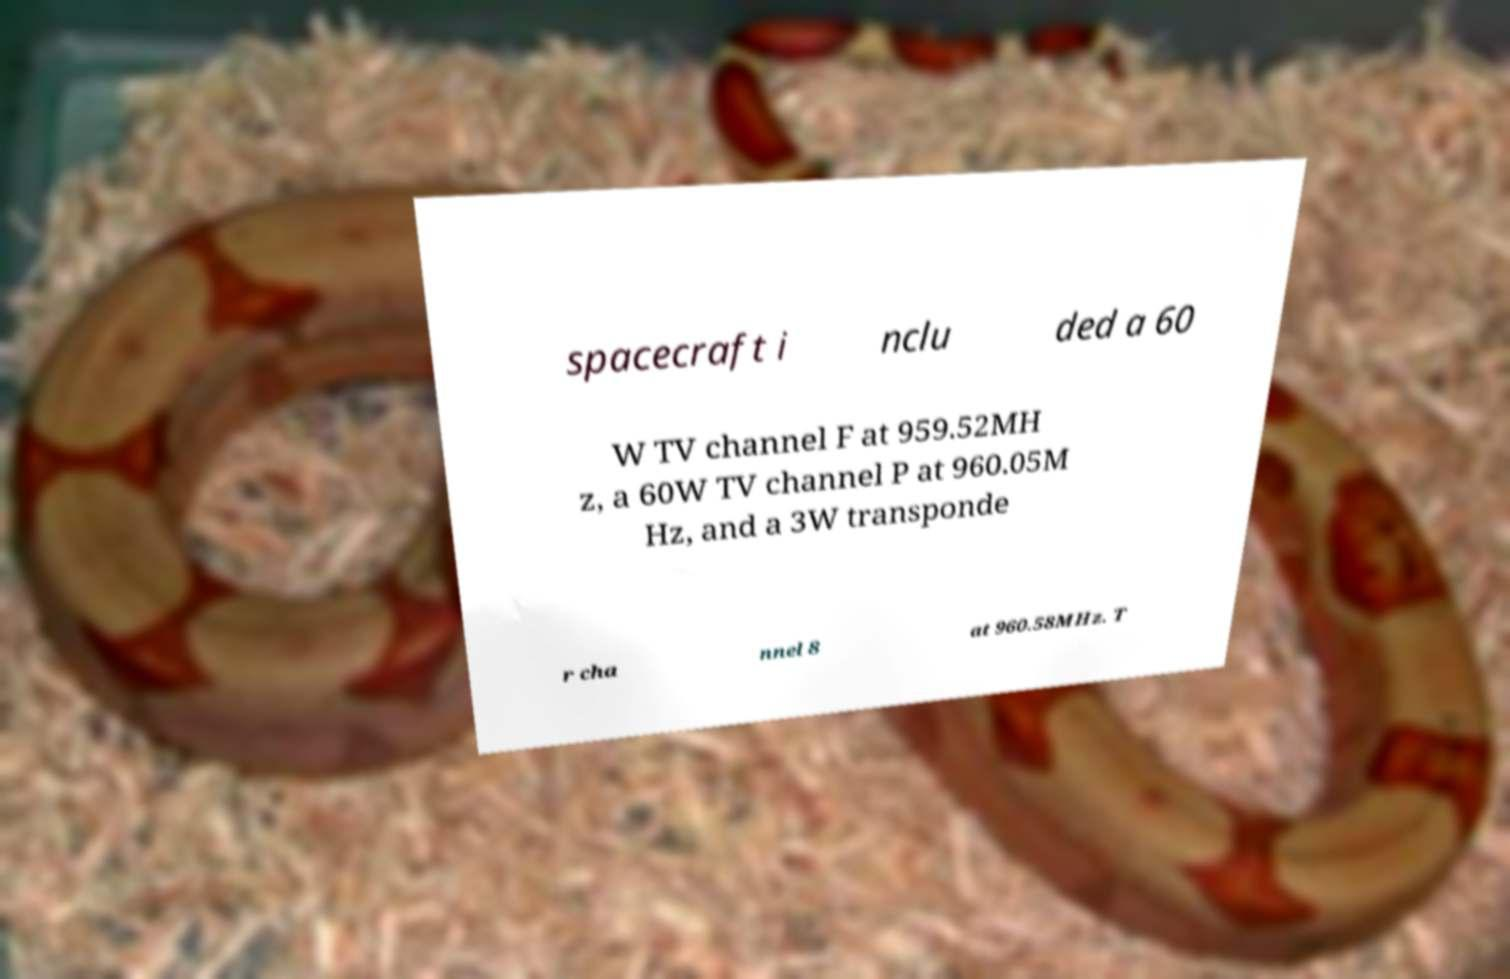There's text embedded in this image that I need extracted. Can you transcribe it verbatim? spacecraft i nclu ded a 60 W TV channel F at 959.52MH z, a 60W TV channel P at 960.05M Hz, and a 3W transponde r cha nnel 8 at 960.58MHz. T 